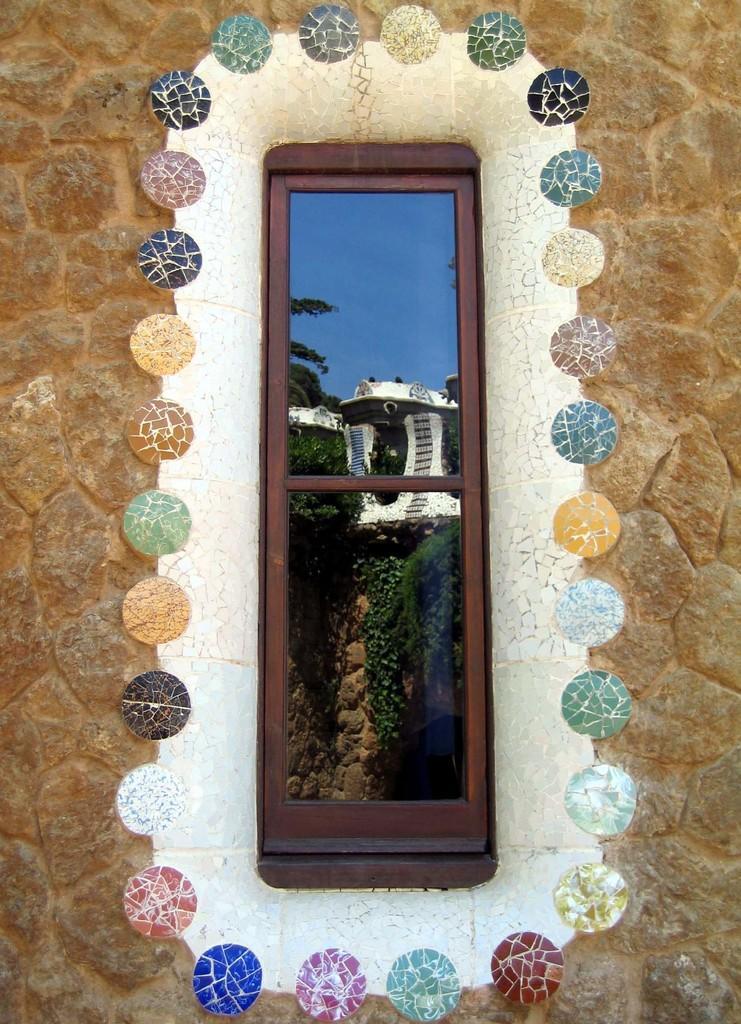Describe this image in one or two sentences. There is a brick wall. On that there is a window. Around the window there are stones in different color. On the window we can see some trees, sky and a white color building. 